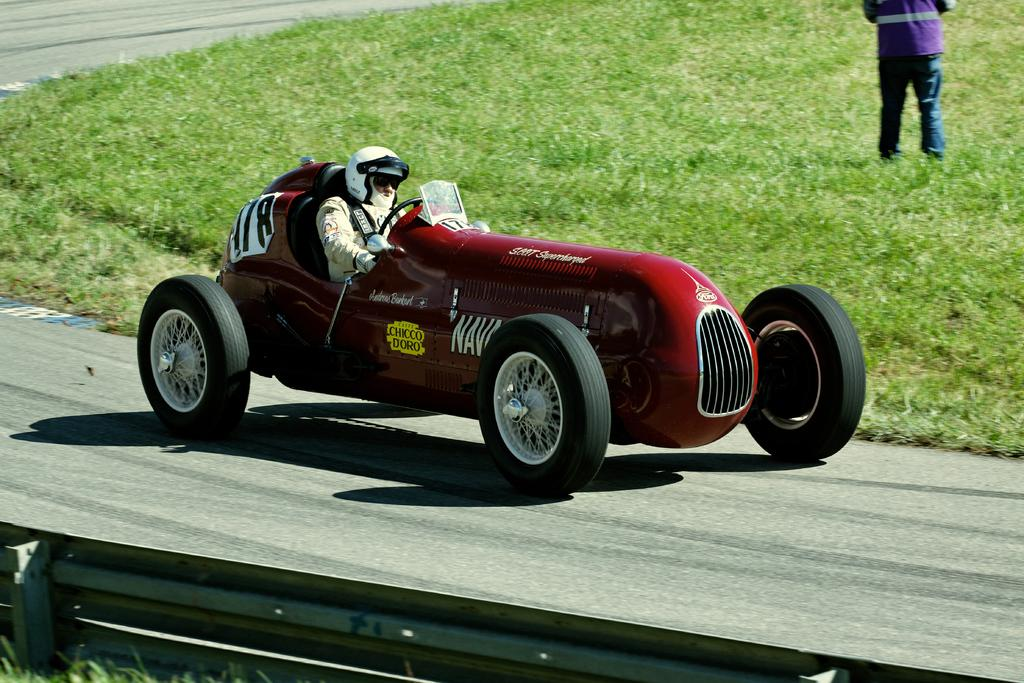What is the man in the image doing? The man is sitting in the image. What is the man wearing on his head? The man is wearing a helmet. What is the man riding in the image? The man is riding a vehicle. What color is the vehicle the man is riding? The vehicle is red in color. What is the other man in the image doing? The other man is standing on the grass in the image. What position does the zebra hold in the image? There is no zebra present in the image. What type of slave is depicted in the image? There is no slave depicted in the image. 